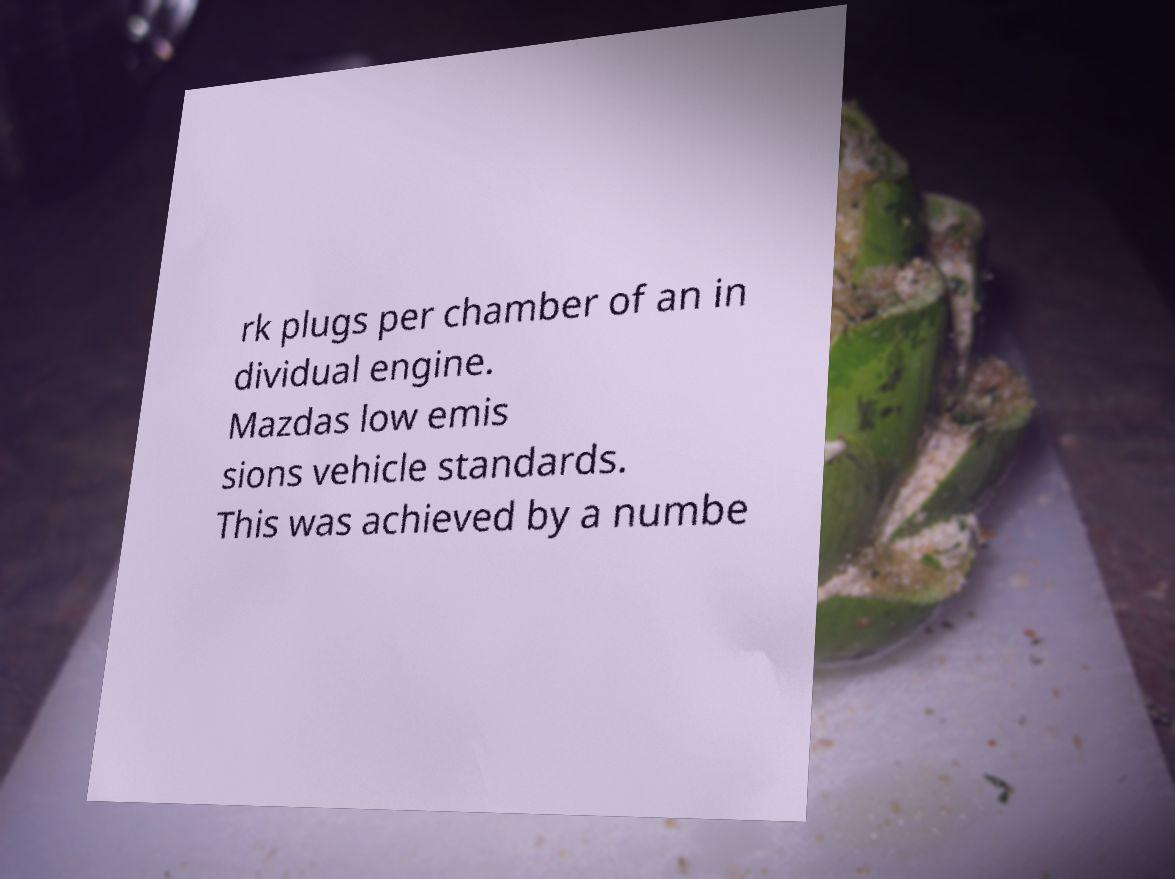Can you read and provide the text displayed in the image?This photo seems to have some interesting text. Can you extract and type it out for me? rk plugs per chamber of an in dividual engine. Mazdas low emis sions vehicle standards. This was achieved by a numbe 